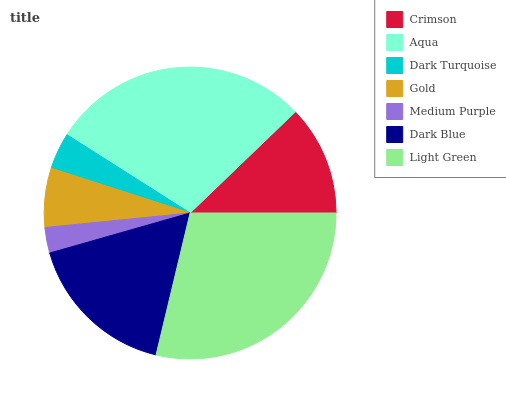Is Medium Purple the minimum?
Answer yes or no. Yes. Is Aqua the maximum?
Answer yes or no. Yes. Is Dark Turquoise the minimum?
Answer yes or no. No. Is Dark Turquoise the maximum?
Answer yes or no. No. Is Aqua greater than Dark Turquoise?
Answer yes or no. Yes. Is Dark Turquoise less than Aqua?
Answer yes or no. Yes. Is Dark Turquoise greater than Aqua?
Answer yes or no. No. Is Aqua less than Dark Turquoise?
Answer yes or no. No. Is Crimson the high median?
Answer yes or no. Yes. Is Crimson the low median?
Answer yes or no. Yes. Is Medium Purple the high median?
Answer yes or no. No. Is Medium Purple the low median?
Answer yes or no. No. 